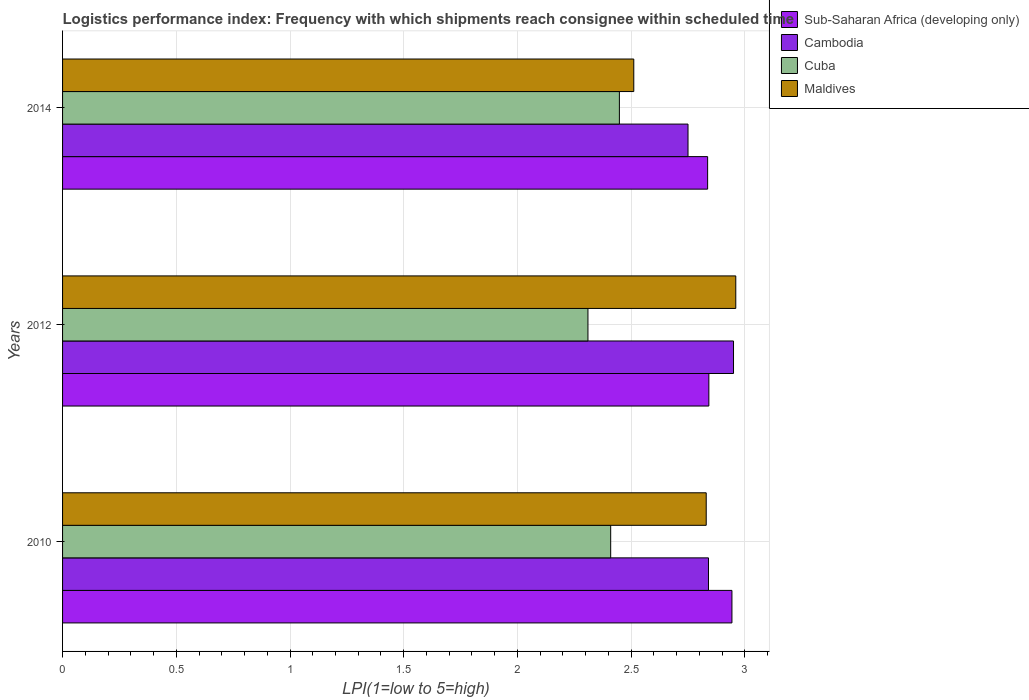How many groups of bars are there?
Offer a terse response. 3. What is the label of the 1st group of bars from the top?
Keep it short and to the point. 2014. In how many cases, is the number of bars for a given year not equal to the number of legend labels?
Your answer should be very brief. 0. What is the logistics performance index in Sub-Saharan Africa (developing only) in 2012?
Make the answer very short. 2.84. Across all years, what is the maximum logistics performance index in Cambodia?
Your answer should be very brief. 2.95. Across all years, what is the minimum logistics performance index in Cambodia?
Offer a terse response. 2.75. In which year was the logistics performance index in Sub-Saharan Africa (developing only) maximum?
Provide a short and direct response. 2010. What is the total logistics performance index in Cambodia in the graph?
Keep it short and to the point. 8.54. What is the difference between the logistics performance index in Cuba in 2010 and that in 2012?
Offer a very short reply. 0.1. What is the difference between the logistics performance index in Maldives in 2014 and the logistics performance index in Cuba in 2012?
Provide a succinct answer. 0.2. What is the average logistics performance index in Cambodia per year?
Ensure brevity in your answer.  2.85. In the year 2012, what is the difference between the logistics performance index in Maldives and logistics performance index in Cuba?
Give a very brief answer. 0.65. What is the ratio of the logistics performance index in Cuba in 2010 to that in 2014?
Give a very brief answer. 0.98. What is the difference between the highest and the second highest logistics performance index in Sub-Saharan Africa (developing only)?
Provide a short and direct response. 0.1. What is the difference between the highest and the lowest logistics performance index in Sub-Saharan Africa (developing only)?
Give a very brief answer. 0.11. In how many years, is the logistics performance index in Cambodia greater than the average logistics performance index in Cambodia taken over all years?
Your answer should be compact. 1. Is the sum of the logistics performance index in Maldives in 2012 and 2014 greater than the maximum logistics performance index in Cambodia across all years?
Your answer should be compact. Yes. Is it the case that in every year, the sum of the logistics performance index in Maldives and logistics performance index in Sub-Saharan Africa (developing only) is greater than the sum of logistics performance index in Cuba and logistics performance index in Cambodia?
Offer a very short reply. Yes. What does the 4th bar from the top in 2010 represents?
Offer a very short reply. Sub-Saharan Africa (developing only). What does the 2nd bar from the bottom in 2012 represents?
Ensure brevity in your answer.  Cambodia. How many bars are there?
Keep it short and to the point. 12. Are all the bars in the graph horizontal?
Your answer should be very brief. Yes. How many years are there in the graph?
Your response must be concise. 3. Are the values on the major ticks of X-axis written in scientific E-notation?
Ensure brevity in your answer.  No. Does the graph contain grids?
Your answer should be compact. Yes. What is the title of the graph?
Provide a short and direct response. Logistics performance index: Frequency with which shipments reach consignee within scheduled time. Does "Caribbean small states" appear as one of the legend labels in the graph?
Offer a very short reply. No. What is the label or title of the X-axis?
Make the answer very short. LPI(1=low to 5=high). What is the label or title of the Y-axis?
Provide a succinct answer. Years. What is the LPI(1=low to 5=high) in Sub-Saharan Africa (developing only) in 2010?
Provide a short and direct response. 2.94. What is the LPI(1=low to 5=high) in Cambodia in 2010?
Keep it short and to the point. 2.84. What is the LPI(1=low to 5=high) in Cuba in 2010?
Offer a terse response. 2.41. What is the LPI(1=low to 5=high) in Maldives in 2010?
Keep it short and to the point. 2.83. What is the LPI(1=low to 5=high) in Sub-Saharan Africa (developing only) in 2012?
Provide a succinct answer. 2.84. What is the LPI(1=low to 5=high) of Cambodia in 2012?
Your answer should be very brief. 2.95. What is the LPI(1=low to 5=high) in Cuba in 2012?
Keep it short and to the point. 2.31. What is the LPI(1=low to 5=high) in Maldives in 2012?
Your answer should be compact. 2.96. What is the LPI(1=low to 5=high) in Sub-Saharan Africa (developing only) in 2014?
Provide a short and direct response. 2.84. What is the LPI(1=low to 5=high) of Cambodia in 2014?
Provide a succinct answer. 2.75. What is the LPI(1=low to 5=high) of Cuba in 2014?
Your response must be concise. 2.45. What is the LPI(1=low to 5=high) of Maldives in 2014?
Give a very brief answer. 2.51. Across all years, what is the maximum LPI(1=low to 5=high) of Sub-Saharan Africa (developing only)?
Your response must be concise. 2.94. Across all years, what is the maximum LPI(1=low to 5=high) of Cambodia?
Your response must be concise. 2.95. Across all years, what is the maximum LPI(1=low to 5=high) of Cuba?
Your response must be concise. 2.45. Across all years, what is the maximum LPI(1=low to 5=high) in Maldives?
Provide a short and direct response. 2.96. Across all years, what is the minimum LPI(1=low to 5=high) of Sub-Saharan Africa (developing only)?
Ensure brevity in your answer.  2.84. Across all years, what is the minimum LPI(1=low to 5=high) of Cambodia?
Offer a very short reply. 2.75. Across all years, what is the minimum LPI(1=low to 5=high) of Cuba?
Give a very brief answer. 2.31. Across all years, what is the minimum LPI(1=low to 5=high) in Maldives?
Give a very brief answer. 2.51. What is the total LPI(1=low to 5=high) of Sub-Saharan Africa (developing only) in the graph?
Your answer should be compact. 8.62. What is the total LPI(1=low to 5=high) in Cambodia in the graph?
Your response must be concise. 8.54. What is the total LPI(1=low to 5=high) of Cuba in the graph?
Provide a short and direct response. 7.17. What is the total LPI(1=low to 5=high) of Maldives in the graph?
Offer a terse response. 8.3. What is the difference between the LPI(1=low to 5=high) in Sub-Saharan Africa (developing only) in 2010 and that in 2012?
Make the answer very short. 0.1. What is the difference between the LPI(1=low to 5=high) in Cambodia in 2010 and that in 2012?
Provide a succinct answer. -0.11. What is the difference between the LPI(1=low to 5=high) of Maldives in 2010 and that in 2012?
Provide a short and direct response. -0.13. What is the difference between the LPI(1=low to 5=high) of Sub-Saharan Africa (developing only) in 2010 and that in 2014?
Your answer should be compact. 0.11. What is the difference between the LPI(1=low to 5=high) of Cambodia in 2010 and that in 2014?
Make the answer very short. 0.09. What is the difference between the LPI(1=low to 5=high) of Cuba in 2010 and that in 2014?
Offer a terse response. -0.04. What is the difference between the LPI(1=low to 5=high) in Maldives in 2010 and that in 2014?
Provide a succinct answer. 0.32. What is the difference between the LPI(1=low to 5=high) in Sub-Saharan Africa (developing only) in 2012 and that in 2014?
Offer a very short reply. 0.01. What is the difference between the LPI(1=low to 5=high) in Cuba in 2012 and that in 2014?
Your response must be concise. -0.14. What is the difference between the LPI(1=low to 5=high) of Maldives in 2012 and that in 2014?
Give a very brief answer. 0.45. What is the difference between the LPI(1=low to 5=high) of Sub-Saharan Africa (developing only) in 2010 and the LPI(1=low to 5=high) of Cambodia in 2012?
Your response must be concise. -0.01. What is the difference between the LPI(1=low to 5=high) in Sub-Saharan Africa (developing only) in 2010 and the LPI(1=low to 5=high) in Cuba in 2012?
Ensure brevity in your answer.  0.63. What is the difference between the LPI(1=low to 5=high) in Sub-Saharan Africa (developing only) in 2010 and the LPI(1=low to 5=high) in Maldives in 2012?
Your response must be concise. -0.02. What is the difference between the LPI(1=low to 5=high) in Cambodia in 2010 and the LPI(1=low to 5=high) in Cuba in 2012?
Ensure brevity in your answer.  0.53. What is the difference between the LPI(1=low to 5=high) in Cambodia in 2010 and the LPI(1=low to 5=high) in Maldives in 2012?
Give a very brief answer. -0.12. What is the difference between the LPI(1=low to 5=high) of Cuba in 2010 and the LPI(1=low to 5=high) of Maldives in 2012?
Your answer should be compact. -0.55. What is the difference between the LPI(1=low to 5=high) in Sub-Saharan Africa (developing only) in 2010 and the LPI(1=low to 5=high) in Cambodia in 2014?
Provide a short and direct response. 0.19. What is the difference between the LPI(1=low to 5=high) in Sub-Saharan Africa (developing only) in 2010 and the LPI(1=low to 5=high) in Cuba in 2014?
Provide a short and direct response. 0.49. What is the difference between the LPI(1=low to 5=high) of Sub-Saharan Africa (developing only) in 2010 and the LPI(1=low to 5=high) of Maldives in 2014?
Give a very brief answer. 0.43. What is the difference between the LPI(1=low to 5=high) of Cambodia in 2010 and the LPI(1=low to 5=high) of Cuba in 2014?
Provide a succinct answer. 0.39. What is the difference between the LPI(1=low to 5=high) in Cambodia in 2010 and the LPI(1=low to 5=high) in Maldives in 2014?
Offer a very short reply. 0.33. What is the difference between the LPI(1=low to 5=high) of Cuba in 2010 and the LPI(1=low to 5=high) of Maldives in 2014?
Your answer should be very brief. -0.1. What is the difference between the LPI(1=low to 5=high) in Sub-Saharan Africa (developing only) in 2012 and the LPI(1=low to 5=high) in Cambodia in 2014?
Your answer should be very brief. 0.09. What is the difference between the LPI(1=low to 5=high) of Sub-Saharan Africa (developing only) in 2012 and the LPI(1=low to 5=high) of Cuba in 2014?
Ensure brevity in your answer.  0.39. What is the difference between the LPI(1=low to 5=high) in Sub-Saharan Africa (developing only) in 2012 and the LPI(1=low to 5=high) in Maldives in 2014?
Your answer should be very brief. 0.33. What is the difference between the LPI(1=low to 5=high) in Cambodia in 2012 and the LPI(1=low to 5=high) in Cuba in 2014?
Offer a terse response. 0.5. What is the difference between the LPI(1=low to 5=high) of Cambodia in 2012 and the LPI(1=low to 5=high) of Maldives in 2014?
Provide a succinct answer. 0.44. What is the difference between the LPI(1=low to 5=high) of Cuba in 2012 and the LPI(1=low to 5=high) of Maldives in 2014?
Offer a very short reply. -0.2. What is the average LPI(1=low to 5=high) in Sub-Saharan Africa (developing only) per year?
Offer a terse response. 2.87. What is the average LPI(1=low to 5=high) in Cambodia per year?
Your response must be concise. 2.85. What is the average LPI(1=low to 5=high) in Cuba per year?
Provide a succinct answer. 2.39. What is the average LPI(1=low to 5=high) in Maldives per year?
Offer a very short reply. 2.77. In the year 2010, what is the difference between the LPI(1=low to 5=high) in Sub-Saharan Africa (developing only) and LPI(1=low to 5=high) in Cambodia?
Ensure brevity in your answer.  0.1. In the year 2010, what is the difference between the LPI(1=low to 5=high) in Sub-Saharan Africa (developing only) and LPI(1=low to 5=high) in Cuba?
Your answer should be very brief. 0.53. In the year 2010, what is the difference between the LPI(1=low to 5=high) of Sub-Saharan Africa (developing only) and LPI(1=low to 5=high) of Maldives?
Your response must be concise. 0.11. In the year 2010, what is the difference between the LPI(1=low to 5=high) of Cambodia and LPI(1=low to 5=high) of Cuba?
Offer a very short reply. 0.43. In the year 2010, what is the difference between the LPI(1=low to 5=high) in Cambodia and LPI(1=low to 5=high) in Maldives?
Give a very brief answer. 0.01. In the year 2010, what is the difference between the LPI(1=low to 5=high) in Cuba and LPI(1=low to 5=high) in Maldives?
Provide a succinct answer. -0.42. In the year 2012, what is the difference between the LPI(1=low to 5=high) in Sub-Saharan Africa (developing only) and LPI(1=low to 5=high) in Cambodia?
Offer a terse response. -0.11. In the year 2012, what is the difference between the LPI(1=low to 5=high) in Sub-Saharan Africa (developing only) and LPI(1=low to 5=high) in Cuba?
Offer a very short reply. 0.53. In the year 2012, what is the difference between the LPI(1=low to 5=high) in Sub-Saharan Africa (developing only) and LPI(1=low to 5=high) in Maldives?
Keep it short and to the point. -0.12. In the year 2012, what is the difference between the LPI(1=low to 5=high) of Cambodia and LPI(1=low to 5=high) of Cuba?
Your response must be concise. 0.64. In the year 2012, what is the difference between the LPI(1=low to 5=high) of Cambodia and LPI(1=low to 5=high) of Maldives?
Give a very brief answer. -0.01. In the year 2012, what is the difference between the LPI(1=low to 5=high) of Cuba and LPI(1=low to 5=high) of Maldives?
Provide a succinct answer. -0.65. In the year 2014, what is the difference between the LPI(1=low to 5=high) in Sub-Saharan Africa (developing only) and LPI(1=low to 5=high) in Cambodia?
Offer a very short reply. 0.09. In the year 2014, what is the difference between the LPI(1=low to 5=high) in Sub-Saharan Africa (developing only) and LPI(1=low to 5=high) in Cuba?
Ensure brevity in your answer.  0.39. In the year 2014, what is the difference between the LPI(1=low to 5=high) in Sub-Saharan Africa (developing only) and LPI(1=low to 5=high) in Maldives?
Your answer should be compact. 0.32. In the year 2014, what is the difference between the LPI(1=low to 5=high) of Cambodia and LPI(1=low to 5=high) of Cuba?
Ensure brevity in your answer.  0.3. In the year 2014, what is the difference between the LPI(1=low to 5=high) of Cambodia and LPI(1=low to 5=high) of Maldives?
Provide a succinct answer. 0.24. In the year 2014, what is the difference between the LPI(1=low to 5=high) of Cuba and LPI(1=low to 5=high) of Maldives?
Provide a succinct answer. -0.06. What is the ratio of the LPI(1=low to 5=high) of Sub-Saharan Africa (developing only) in 2010 to that in 2012?
Offer a very short reply. 1.04. What is the ratio of the LPI(1=low to 5=high) in Cambodia in 2010 to that in 2012?
Give a very brief answer. 0.96. What is the ratio of the LPI(1=low to 5=high) in Cuba in 2010 to that in 2012?
Give a very brief answer. 1.04. What is the ratio of the LPI(1=low to 5=high) of Maldives in 2010 to that in 2012?
Your answer should be compact. 0.96. What is the ratio of the LPI(1=low to 5=high) of Sub-Saharan Africa (developing only) in 2010 to that in 2014?
Keep it short and to the point. 1.04. What is the ratio of the LPI(1=low to 5=high) of Cambodia in 2010 to that in 2014?
Your response must be concise. 1.03. What is the ratio of the LPI(1=low to 5=high) of Cuba in 2010 to that in 2014?
Keep it short and to the point. 0.98. What is the ratio of the LPI(1=low to 5=high) in Maldives in 2010 to that in 2014?
Provide a succinct answer. 1.13. What is the ratio of the LPI(1=low to 5=high) of Sub-Saharan Africa (developing only) in 2012 to that in 2014?
Your answer should be compact. 1. What is the ratio of the LPI(1=low to 5=high) in Cambodia in 2012 to that in 2014?
Your answer should be compact. 1.07. What is the ratio of the LPI(1=low to 5=high) in Cuba in 2012 to that in 2014?
Provide a short and direct response. 0.94. What is the ratio of the LPI(1=low to 5=high) of Maldives in 2012 to that in 2014?
Your response must be concise. 1.18. What is the difference between the highest and the second highest LPI(1=low to 5=high) in Sub-Saharan Africa (developing only)?
Make the answer very short. 0.1. What is the difference between the highest and the second highest LPI(1=low to 5=high) in Cambodia?
Make the answer very short. 0.11. What is the difference between the highest and the second highest LPI(1=low to 5=high) of Cuba?
Ensure brevity in your answer.  0.04. What is the difference between the highest and the second highest LPI(1=low to 5=high) in Maldives?
Provide a short and direct response. 0.13. What is the difference between the highest and the lowest LPI(1=low to 5=high) of Sub-Saharan Africa (developing only)?
Provide a succinct answer. 0.11. What is the difference between the highest and the lowest LPI(1=low to 5=high) of Cambodia?
Ensure brevity in your answer.  0.2. What is the difference between the highest and the lowest LPI(1=low to 5=high) of Cuba?
Make the answer very short. 0.14. What is the difference between the highest and the lowest LPI(1=low to 5=high) of Maldives?
Ensure brevity in your answer.  0.45. 